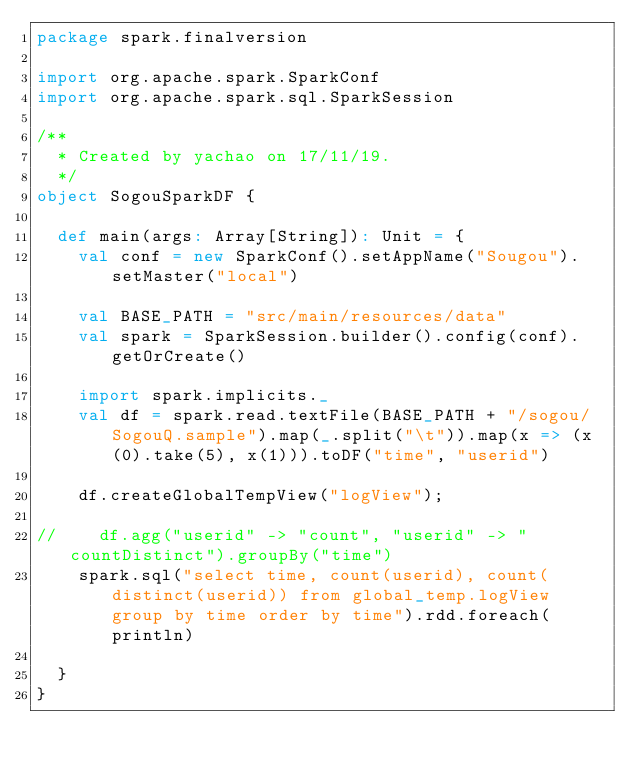Convert code to text. <code><loc_0><loc_0><loc_500><loc_500><_Scala_>package spark.finalversion

import org.apache.spark.SparkConf
import org.apache.spark.sql.SparkSession

/**
  * Created by yachao on 17/11/19.
  */
object SogouSparkDF {

  def main(args: Array[String]): Unit = {
    val conf = new SparkConf().setAppName("Sougou").setMaster("local")

    val BASE_PATH = "src/main/resources/data"
    val spark = SparkSession.builder().config(conf).getOrCreate()

    import spark.implicits._
    val df = spark.read.textFile(BASE_PATH + "/sogou/SogouQ.sample").map(_.split("\t")).map(x => (x(0).take(5), x(1))).toDF("time", "userid")

    df.createGlobalTempView("logView");

//    df.agg("userid" -> "count", "userid" -> "countDistinct").groupBy("time")
    spark.sql("select time, count(userid), count(distinct(userid)) from global_temp.logView group by time order by time").rdd.foreach(println)

  }
}
</code> 